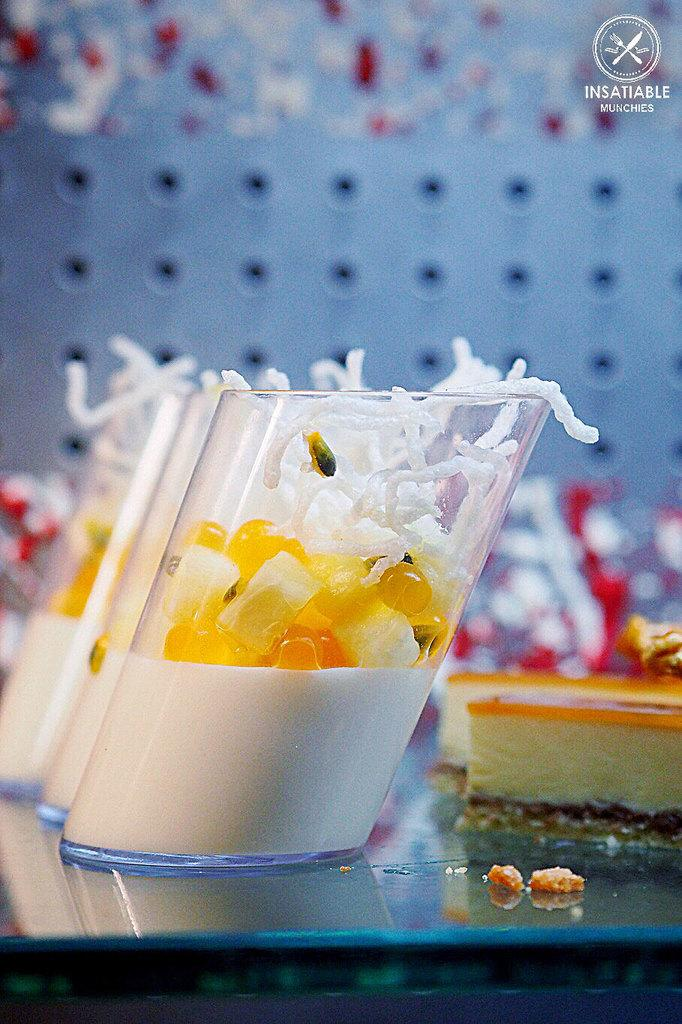What is the main structure visible in the image? There is a platform in the image. What can be found on the platform? Food items and glass vessels with food items are present on the platform. Is there any additional detail in the image? There is a watermark in the right top corner of the image. What type of fly can be seen buzzing around the food on the platform? There is no fly present in the image; it only shows food items and glass vessels on the platform. What type of voice can be heard coming from the arch in the image? There is no arch present in the image, so it's not possible to determine if a voice can be heard from it. 